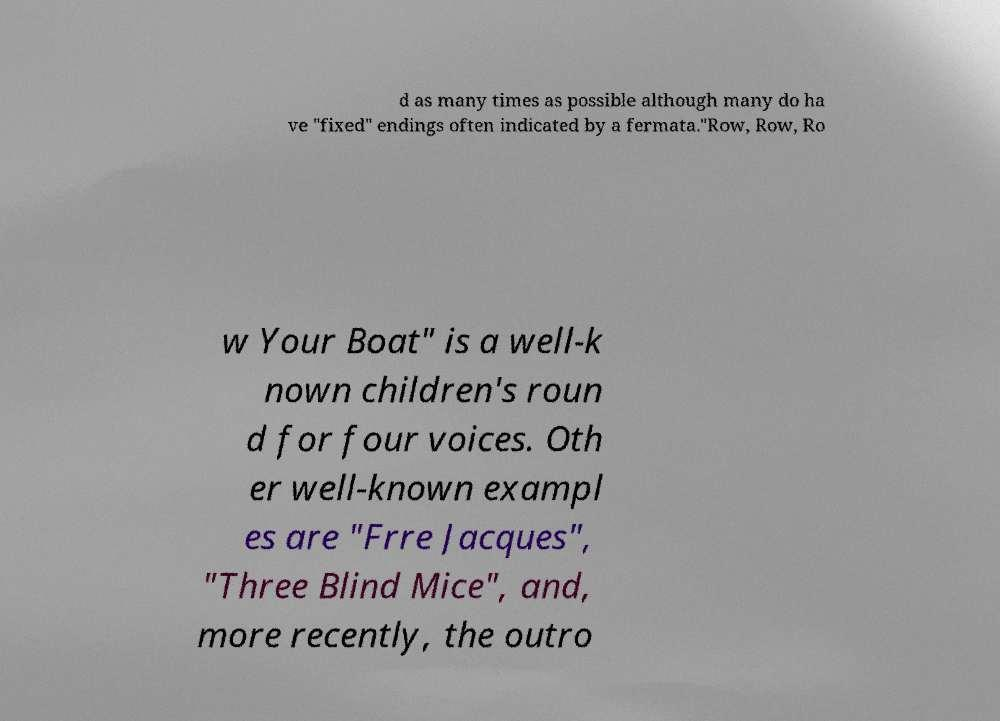Please identify and transcribe the text found in this image. d as many times as possible although many do ha ve "fixed" endings often indicated by a fermata."Row, Row, Ro w Your Boat" is a well-k nown children's roun d for four voices. Oth er well-known exampl es are "Frre Jacques", "Three Blind Mice", and, more recently, the outro 